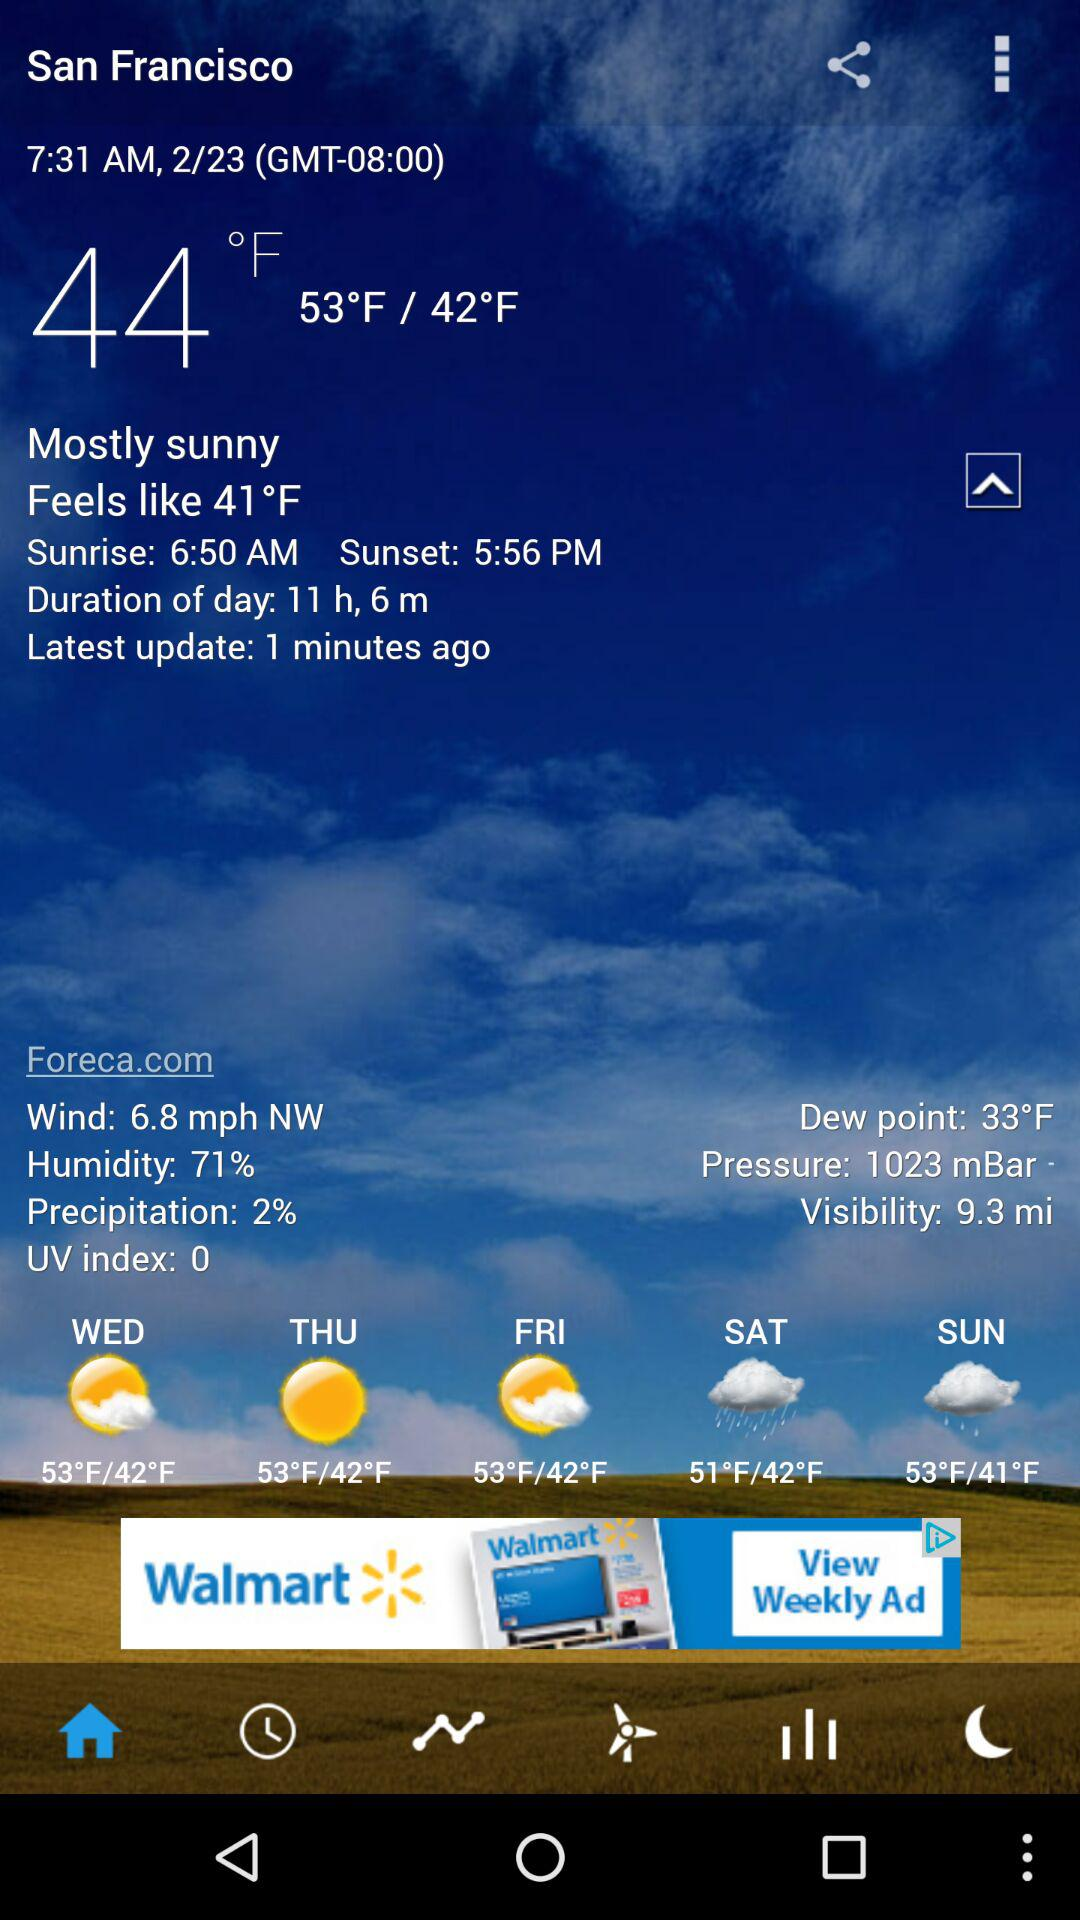What is the pressure? The pressure is 1023 mbar. 